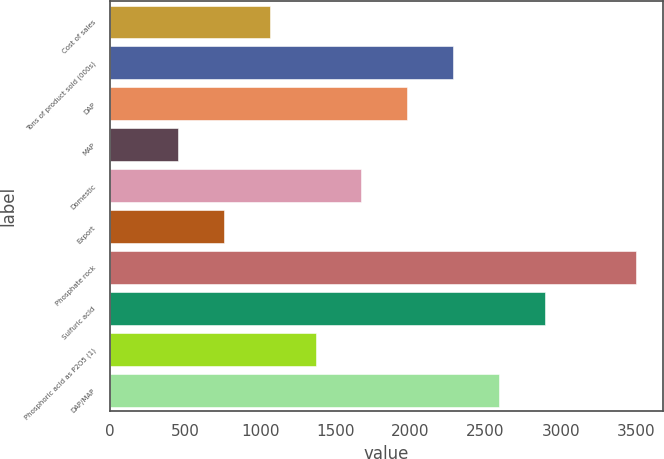Convert chart. <chart><loc_0><loc_0><loc_500><loc_500><bar_chart><fcel>Cost of sales<fcel>Tons of product sold (000s)<fcel>DAP<fcel>MAP<fcel>Domestic<fcel>Export<fcel>Phosphate rock<fcel>Sulfuric acid<fcel>Phosphoric acid as P2O5 (1)<fcel>DAP/MAP<nl><fcel>1064<fcel>2284<fcel>1979<fcel>454<fcel>1674<fcel>759<fcel>3504<fcel>2894<fcel>1369<fcel>2589<nl></chart> 